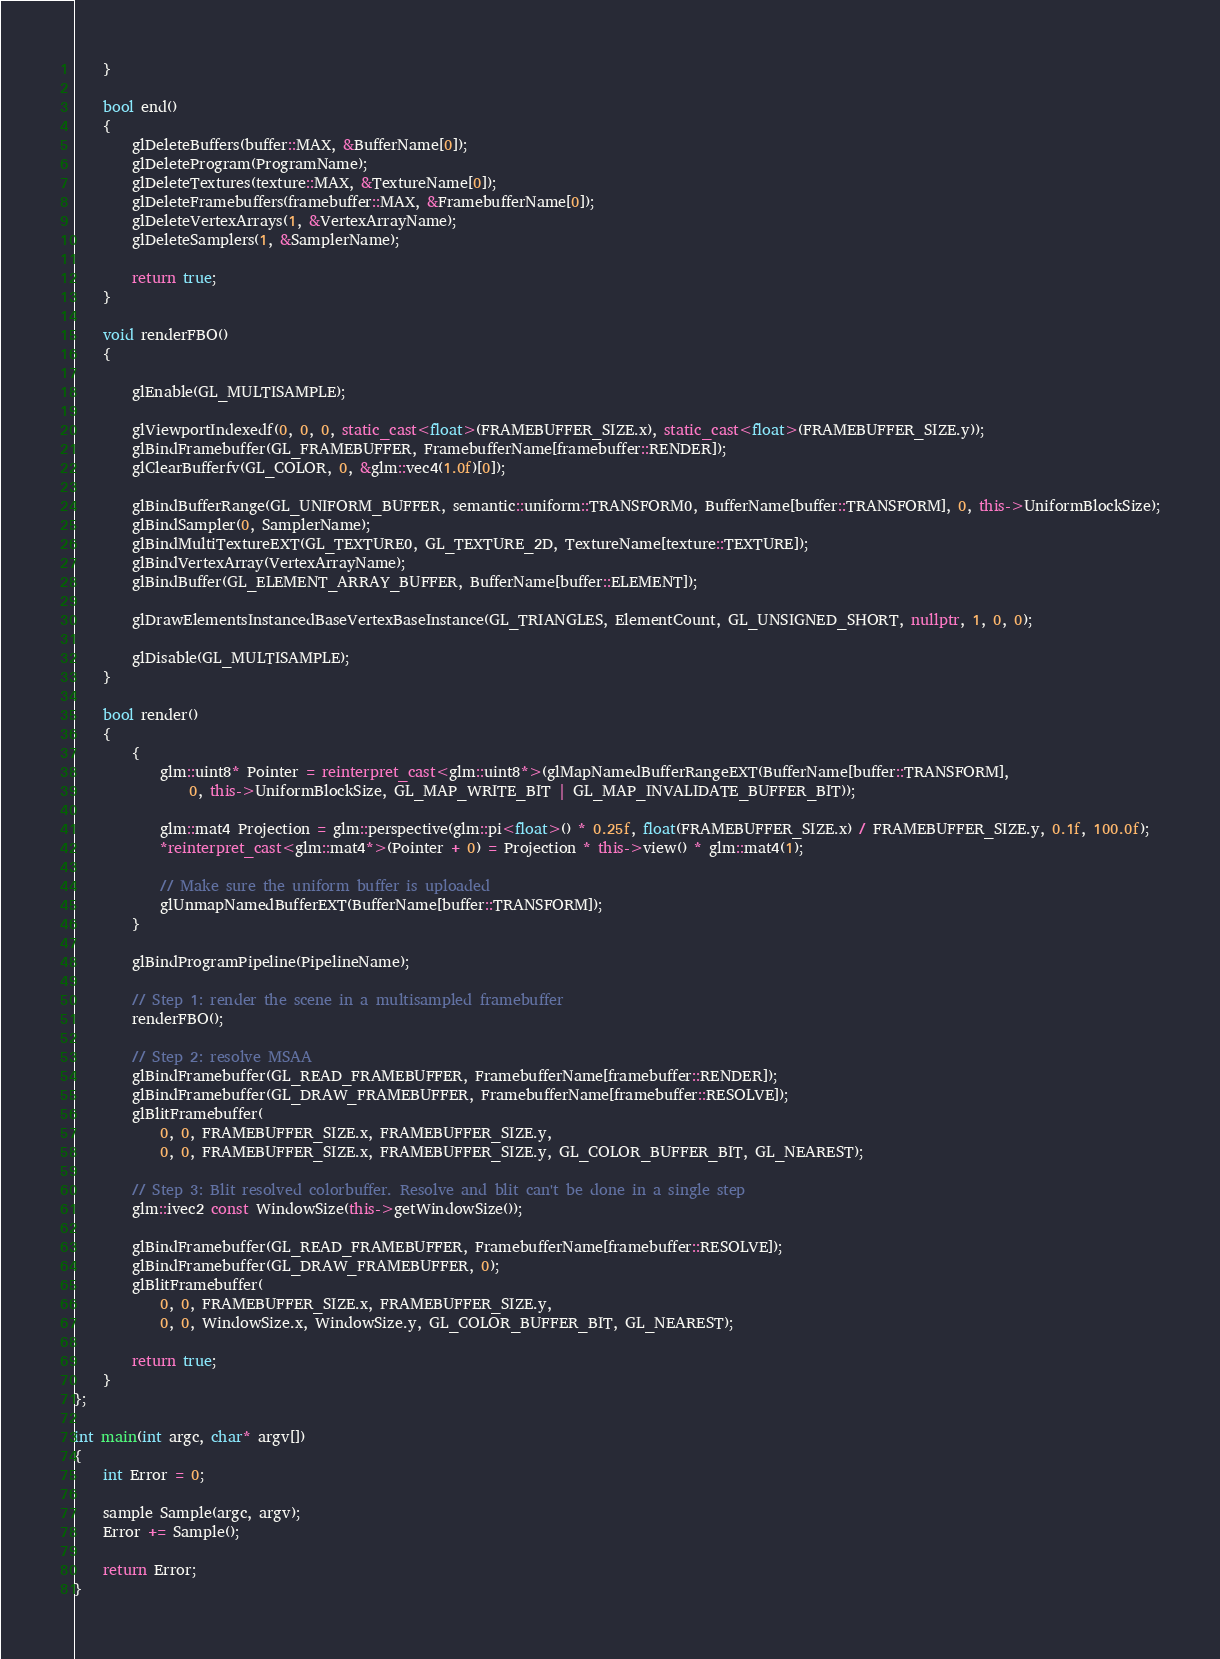Convert code to text. <code><loc_0><loc_0><loc_500><loc_500><_C++_>	}

	bool end()
	{
		glDeleteBuffers(buffer::MAX, &BufferName[0]);
		glDeleteProgram(ProgramName);
		glDeleteTextures(texture::MAX, &TextureName[0]);
		glDeleteFramebuffers(framebuffer::MAX, &FramebufferName[0]);
		glDeleteVertexArrays(1, &VertexArrayName);
		glDeleteSamplers(1, &SamplerName);

		return true;
	}

	void renderFBO()
	{

		glEnable(GL_MULTISAMPLE);

		glViewportIndexedf(0, 0, 0, static_cast<float>(FRAMEBUFFER_SIZE.x), static_cast<float>(FRAMEBUFFER_SIZE.y));
		glBindFramebuffer(GL_FRAMEBUFFER, FramebufferName[framebuffer::RENDER]);
		glClearBufferfv(GL_COLOR, 0, &glm::vec4(1.0f)[0]);

		glBindBufferRange(GL_UNIFORM_BUFFER, semantic::uniform::TRANSFORM0, BufferName[buffer::TRANSFORM], 0, this->UniformBlockSize);
		glBindSampler(0, SamplerName);
		glBindMultiTextureEXT(GL_TEXTURE0, GL_TEXTURE_2D, TextureName[texture::TEXTURE]);
		glBindVertexArray(VertexArrayName);
		glBindBuffer(GL_ELEMENT_ARRAY_BUFFER, BufferName[buffer::ELEMENT]);

		glDrawElementsInstancedBaseVertexBaseInstance(GL_TRIANGLES, ElementCount, GL_UNSIGNED_SHORT, nullptr, 1, 0, 0);

		glDisable(GL_MULTISAMPLE);
	}

	bool render()
	{
		{
			glm::uint8* Pointer = reinterpret_cast<glm::uint8*>(glMapNamedBufferRangeEXT(BufferName[buffer::TRANSFORM],
				0, this->UniformBlockSize, GL_MAP_WRITE_BIT | GL_MAP_INVALIDATE_BUFFER_BIT));

			glm::mat4 Projection = glm::perspective(glm::pi<float>() * 0.25f, float(FRAMEBUFFER_SIZE.x) / FRAMEBUFFER_SIZE.y, 0.1f, 100.0f);
			*reinterpret_cast<glm::mat4*>(Pointer + 0) = Projection * this->view() * glm::mat4(1);

			// Make sure the uniform buffer is uploaded
			glUnmapNamedBufferEXT(BufferName[buffer::TRANSFORM]);
		}

		glBindProgramPipeline(PipelineName);

		// Step 1: render the scene in a multisampled framebuffer
		renderFBO();

		// Step 2: resolve MSAA
		glBindFramebuffer(GL_READ_FRAMEBUFFER, FramebufferName[framebuffer::RENDER]);
		glBindFramebuffer(GL_DRAW_FRAMEBUFFER, FramebufferName[framebuffer::RESOLVE]);
		glBlitFramebuffer(
			0, 0, FRAMEBUFFER_SIZE.x, FRAMEBUFFER_SIZE.y,
			0, 0, FRAMEBUFFER_SIZE.x, FRAMEBUFFER_SIZE.y, GL_COLOR_BUFFER_BIT, GL_NEAREST);

		// Step 3: Blit resolved colorbuffer. Resolve and blit can't be done in a single step
		glm::ivec2 const WindowSize(this->getWindowSize());

		glBindFramebuffer(GL_READ_FRAMEBUFFER, FramebufferName[framebuffer::RESOLVE]);
		glBindFramebuffer(GL_DRAW_FRAMEBUFFER, 0);
		glBlitFramebuffer(
			0, 0, FRAMEBUFFER_SIZE.x, FRAMEBUFFER_SIZE.y,
			0, 0, WindowSize.x, WindowSize.y, GL_COLOR_BUFFER_BIT, GL_NEAREST);

		return true;
	}
};

int main(int argc, char* argv[])
{
	int Error = 0;

	sample Sample(argc, argv);
	Error += Sample();

	return Error;
}

</code> 